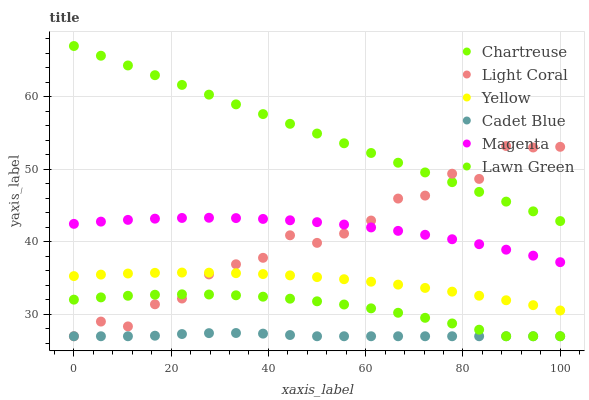Does Cadet Blue have the minimum area under the curve?
Answer yes or no. Yes. Does Chartreuse have the maximum area under the curve?
Answer yes or no. Yes. Does Yellow have the minimum area under the curve?
Answer yes or no. No. Does Yellow have the maximum area under the curve?
Answer yes or no. No. Is Chartreuse the smoothest?
Answer yes or no. Yes. Is Light Coral the roughest?
Answer yes or no. Yes. Is Cadet Blue the smoothest?
Answer yes or no. No. Is Cadet Blue the roughest?
Answer yes or no. No. Does Lawn Green have the lowest value?
Answer yes or no. Yes. Does Yellow have the lowest value?
Answer yes or no. No. Does Chartreuse have the highest value?
Answer yes or no. Yes. Does Yellow have the highest value?
Answer yes or no. No. Is Yellow less than Chartreuse?
Answer yes or no. Yes. Is Chartreuse greater than Cadet Blue?
Answer yes or no. Yes. Does Light Coral intersect Magenta?
Answer yes or no. Yes. Is Light Coral less than Magenta?
Answer yes or no. No. Is Light Coral greater than Magenta?
Answer yes or no. No. Does Yellow intersect Chartreuse?
Answer yes or no. No. 